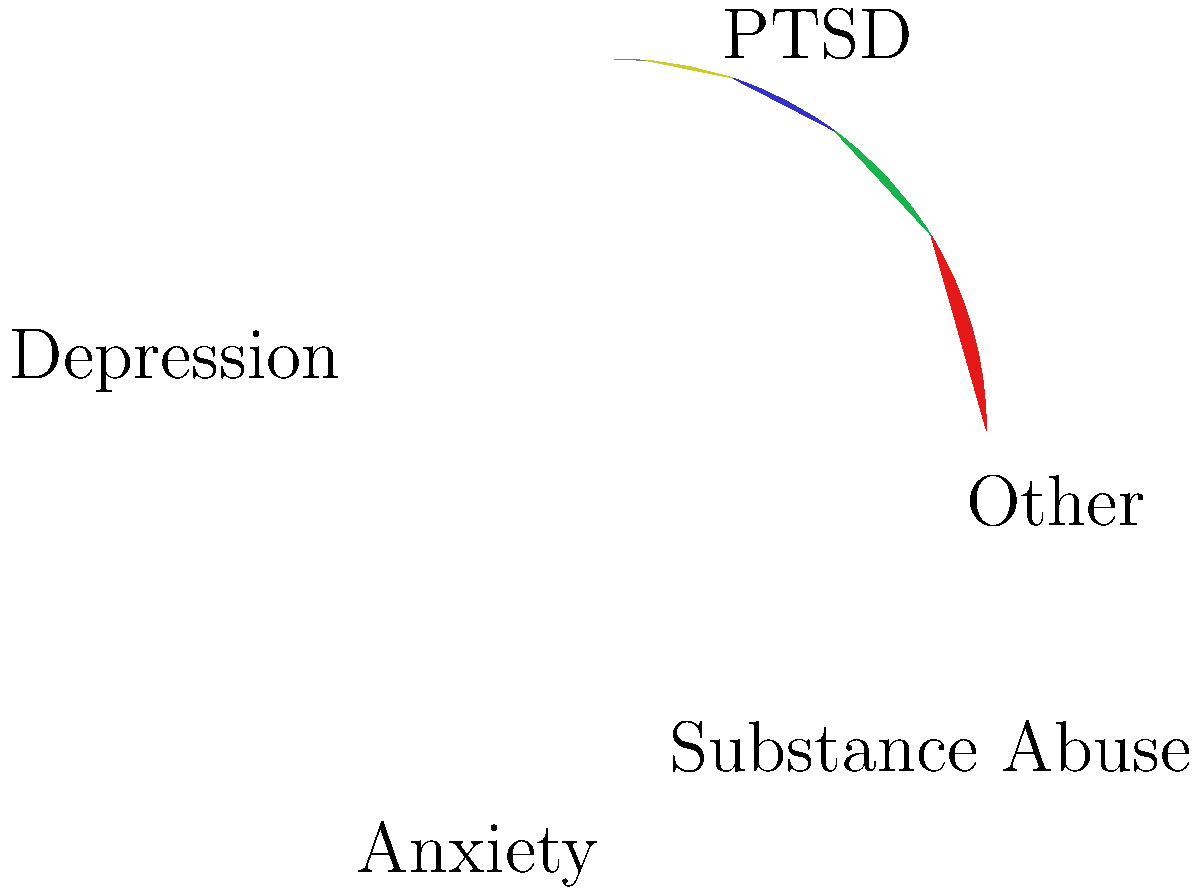In a study on mental health issues among veterans, a pie chart shows the distribution of different conditions. If PTSD accounts for 35% of the cases, what is the central angle (in degrees) of the pie slice representing PTSD? To find the central angle for PTSD in the pie chart, we need to follow these steps:

1. Understand that a full circle contains 360°.

2. Recognize that the percentage of a category in a pie chart corresponds proportionally to its central angle.

3. Set up a proportion:
   $\frac{\text{PTSD percentage}}{100\%} = \frac{\text{PTSD central angle}}{360°}$

4. Plug in the known values:
   $\frac{35\%}{100\%} = \frac{x}{360°}$

5. Cross multiply:
   $35 \times 360° = 100x$

6. Solve for $x$:
   $12,600° = 100x$
   $x = 126°$

Therefore, the central angle for the PTSD slice is 126°.
Answer: 126° 